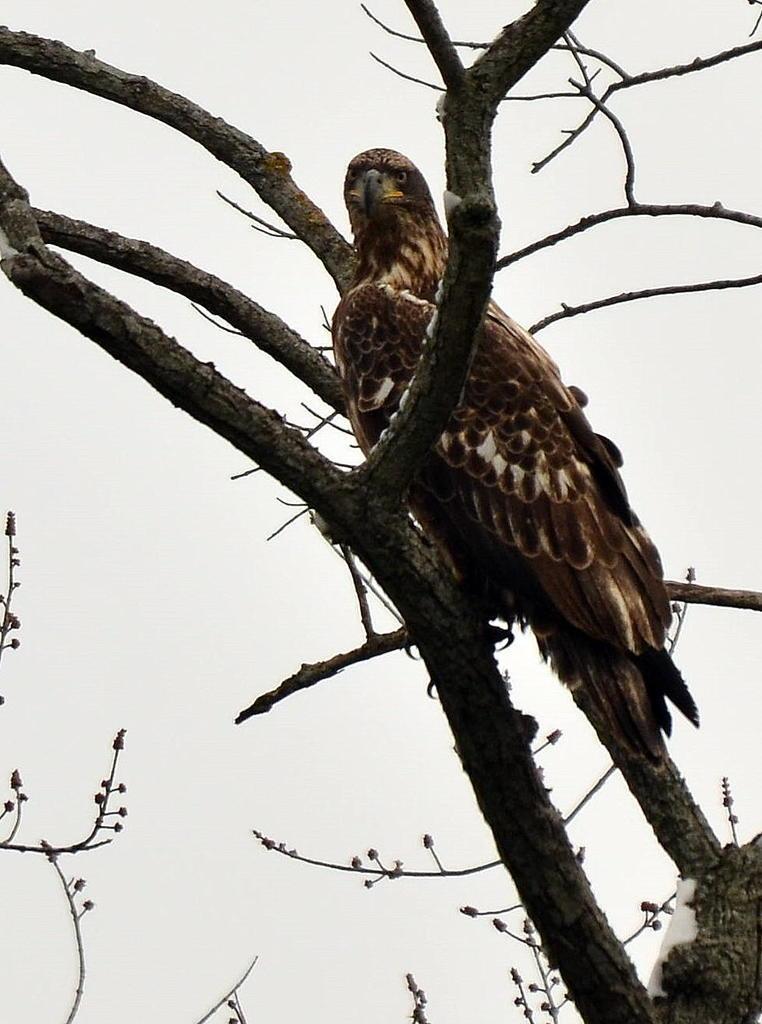Please provide a concise description of this image. In this image I can see a bird sitting on the tree. Bird is in brown color. Background is white in color. 